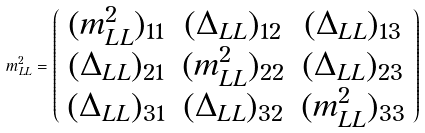<formula> <loc_0><loc_0><loc_500><loc_500>m _ { L L } ^ { 2 } = \left ( \begin{array} { c c c } ( m _ { L L } ^ { 2 } ) _ { 1 1 } & ( \Delta _ { L L } ) _ { 1 2 } & ( \Delta _ { L L } ) _ { 1 3 } \\ ( \Delta _ { L L } ) _ { 2 1 } & ( m ^ { 2 } _ { L L } ) _ { 2 2 } & ( \Delta _ { L L } ) _ { 2 3 } \\ ( \Delta _ { L L } ) _ { 3 1 } & ( \Delta _ { L L } ) _ { 3 2 } & ( m ^ { 2 } _ { L L } ) _ { 3 3 } \\ \end{array} \right )</formula> 